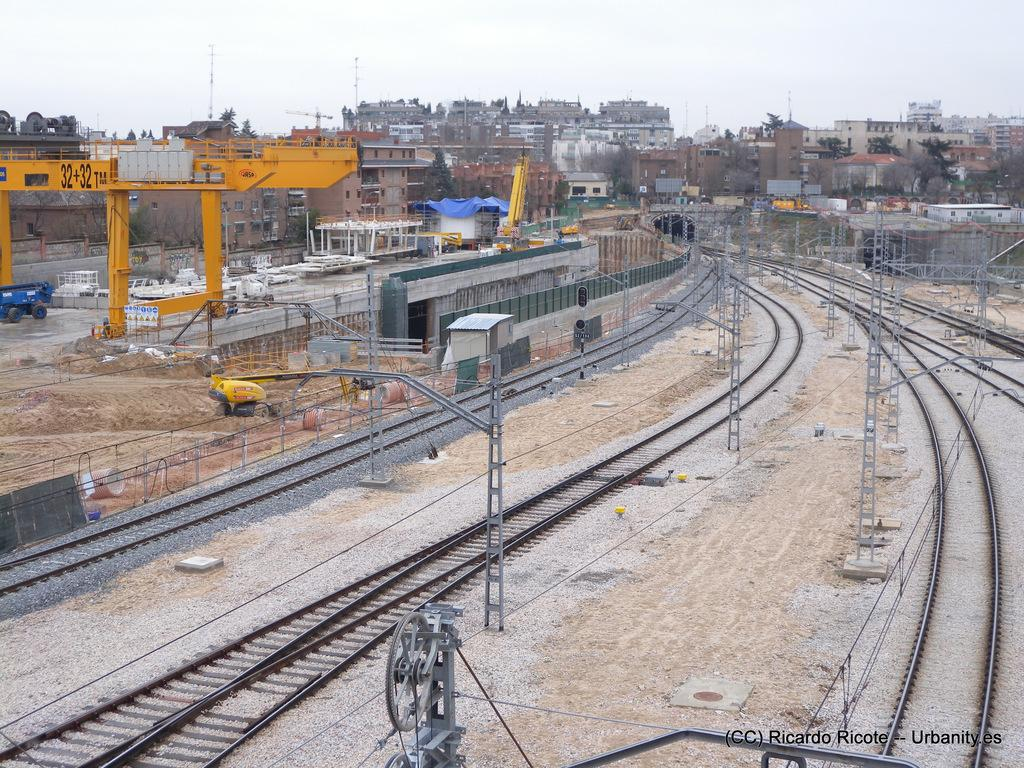<image>
Relay a brief, clear account of the picture shown. the number 32 that is on a yellow item 